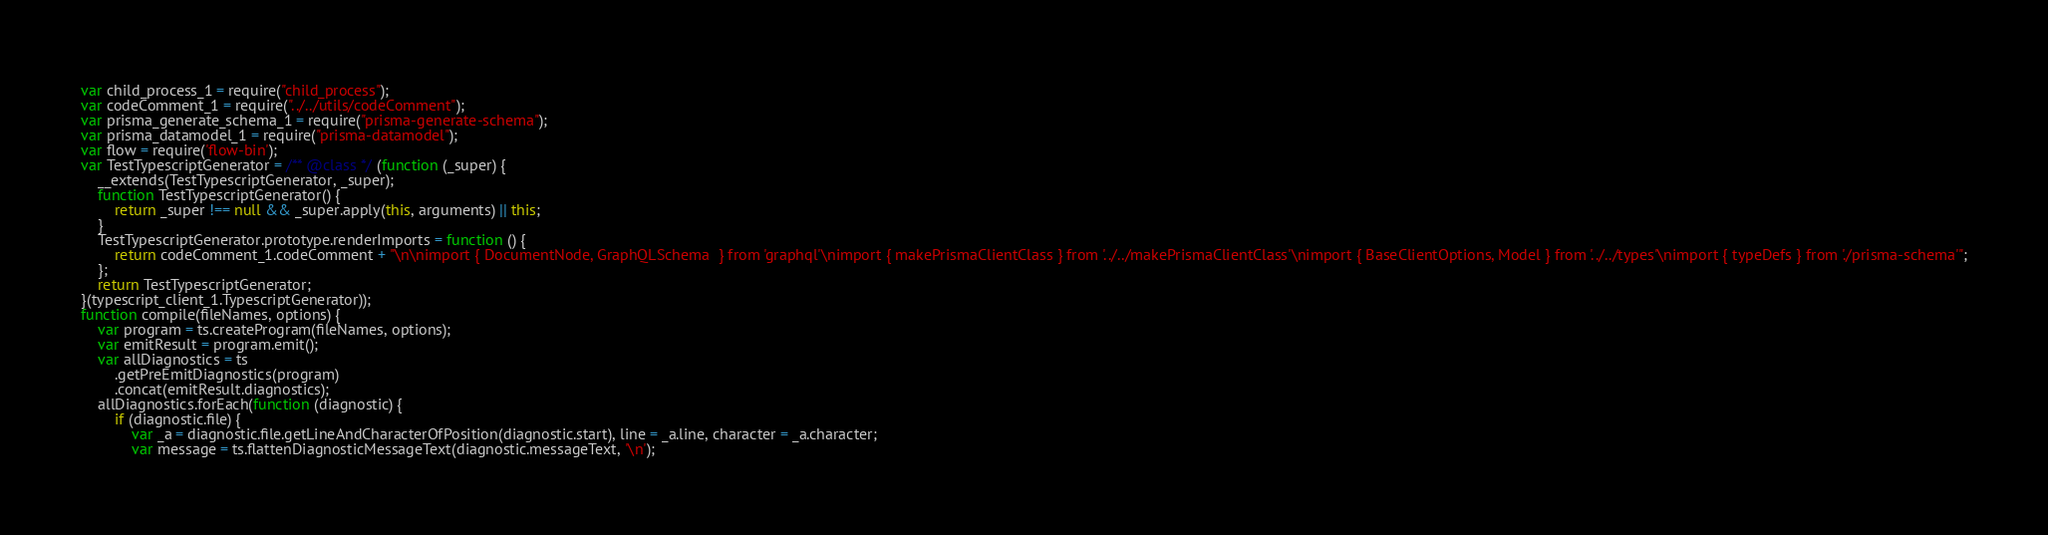Convert code to text. <code><loc_0><loc_0><loc_500><loc_500><_JavaScript_>var child_process_1 = require("child_process");
var codeComment_1 = require("../../utils/codeComment");
var prisma_generate_schema_1 = require("prisma-generate-schema");
var prisma_datamodel_1 = require("prisma-datamodel");
var flow = require('flow-bin');
var TestTypescriptGenerator = /** @class */ (function (_super) {
    __extends(TestTypescriptGenerator, _super);
    function TestTypescriptGenerator() {
        return _super !== null && _super.apply(this, arguments) || this;
    }
    TestTypescriptGenerator.prototype.renderImports = function () {
        return codeComment_1.codeComment + "\n\nimport { DocumentNode, GraphQLSchema  } from 'graphql'\nimport { makePrismaClientClass } from '../../makePrismaClientClass'\nimport { BaseClientOptions, Model } from '../../types'\nimport { typeDefs } from './prisma-schema'";
    };
    return TestTypescriptGenerator;
}(typescript_client_1.TypescriptGenerator));
function compile(fileNames, options) {
    var program = ts.createProgram(fileNames, options);
    var emitResult = program.emit();
    var allDiagnostics = ts
        .getPreEmitDiagnostics(program)
        .concat(emitResult.diagnostics);
    allDiagnostics.forEach(function (diagnostic) {
        if (diagnostic.file) {
            var _a = diagnostic.file.getLineAndCharacterOfPosition(diagnostic.start), line = _a.line, character = _a.character;
            var message = ts.flattenDiagnosticMessageText(diagnostic.messageText, '\n');</code> 